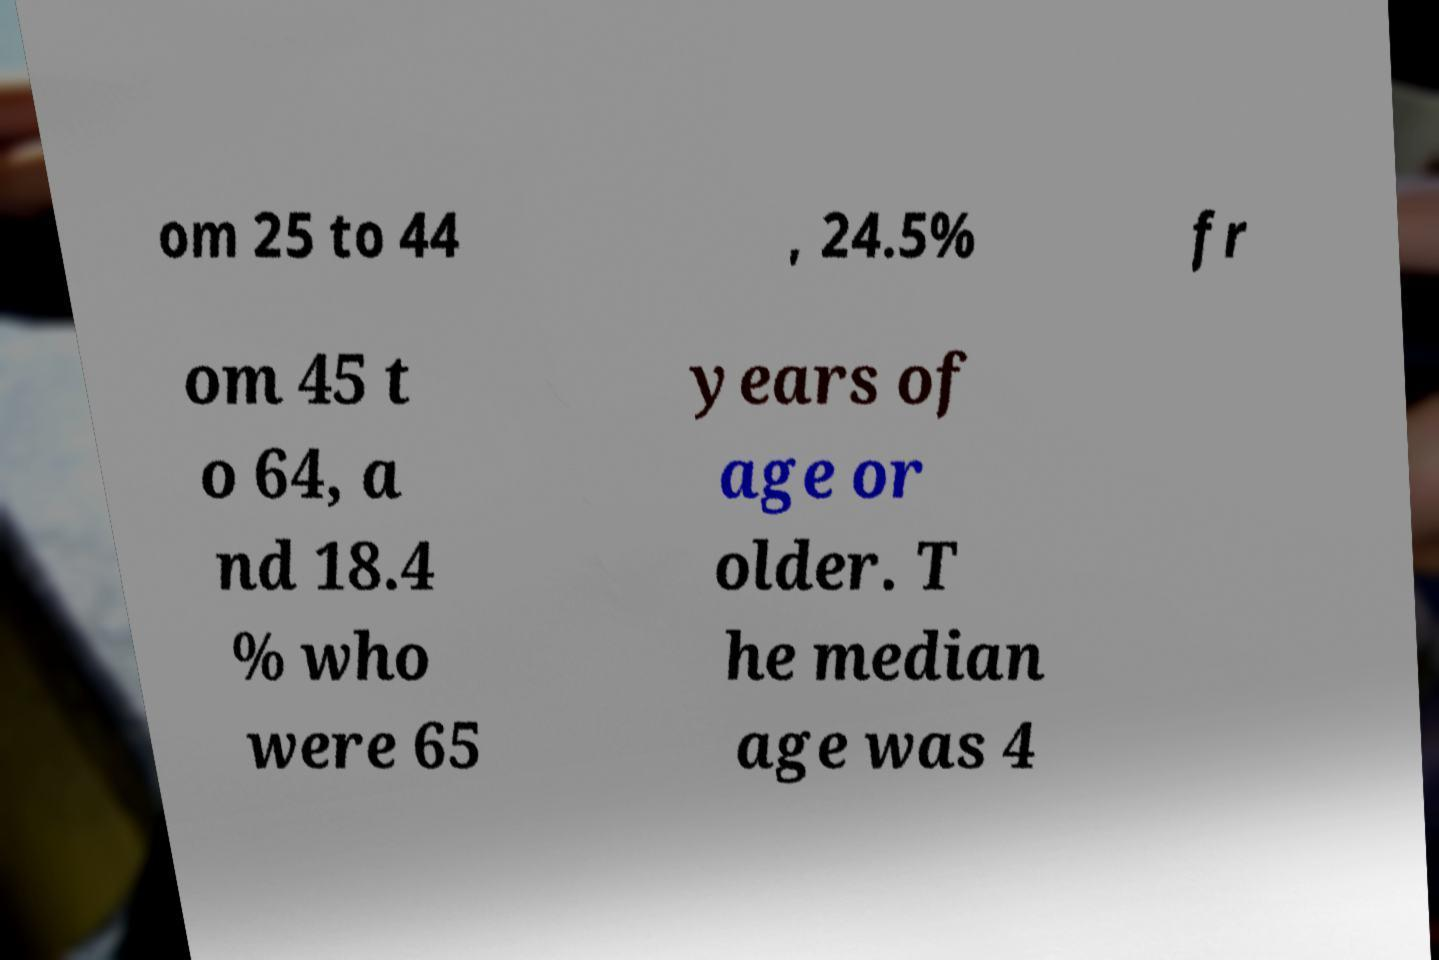Could you extract and type out the text from this image? om 25 to 44 , 24.5% fr om 45 t o 64, a nd 18.4 % who were 65 years of age or older. T he median age was 4 